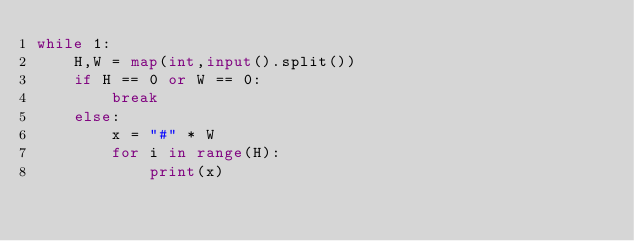Convert code to text. <code><loc_0><loc_0><loc_500><loc_500><_Python_>while 1:
    H,W = map(int,input().split())
    if H == 0 or W == 0:
        break
    else:
        x = "#" * W
        for i in range(H):
            print(x)</code> 